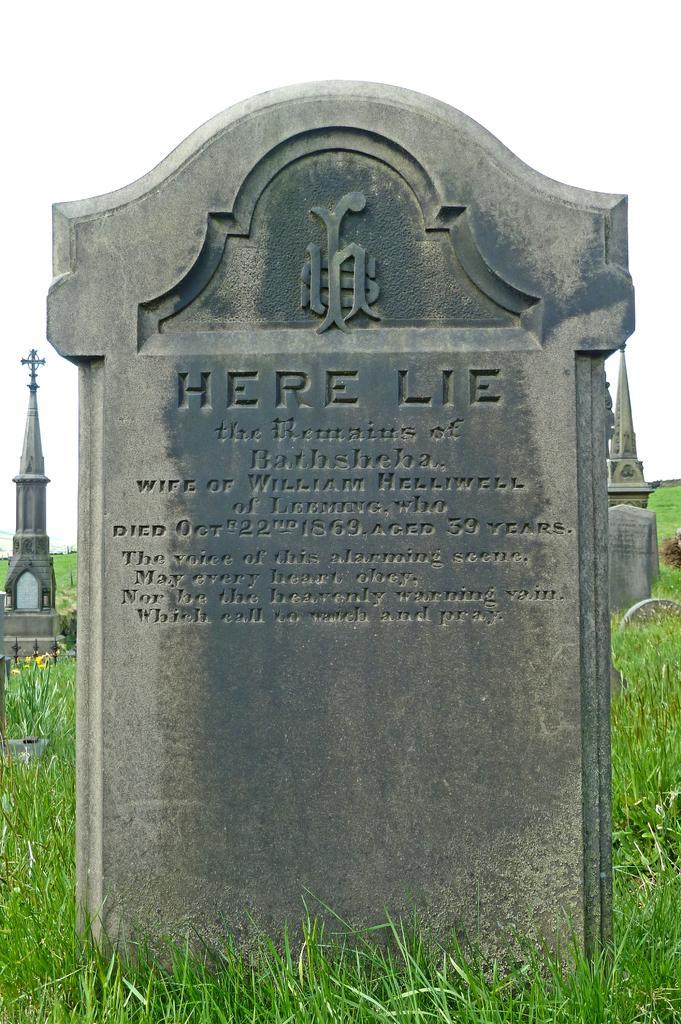Could you give a brief overview of what you see in this image? In this picture I can see a stone which has something written on it. In the background I can see stone objects, grass and the sky. 